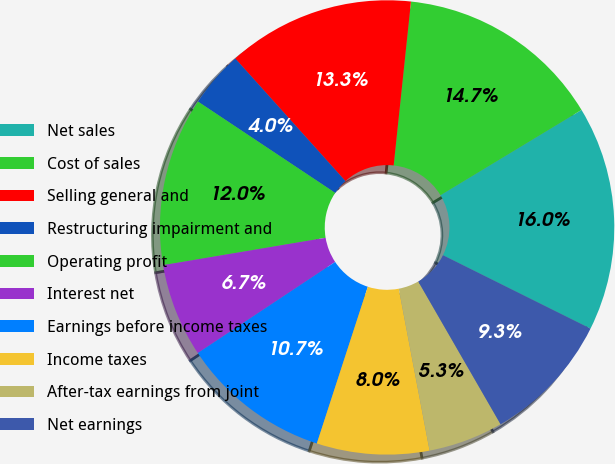<chart> <loc_0><loc_0><loc_500><loc_500><pie_chart><fcel>Net sales<fcel>Cost of sales<fcel>Selling general and<fcel>Restructuring impairment and<fcel>Operating profit<fcel>Interest net<fcel>Earnings before income taxes<fcel>Income taxes<fcel>After-tax earnings from joint<fcel>Net earnings<nl><fcel>16.0%<fcel>14.67%<fcel>13.33%<fcel>4.0%<fcel>12.0%<fcel>6.67%<fcel>10.67%<fcel>8.0%<fcel>5.33%<fcel>9.33%<nl></chart> 